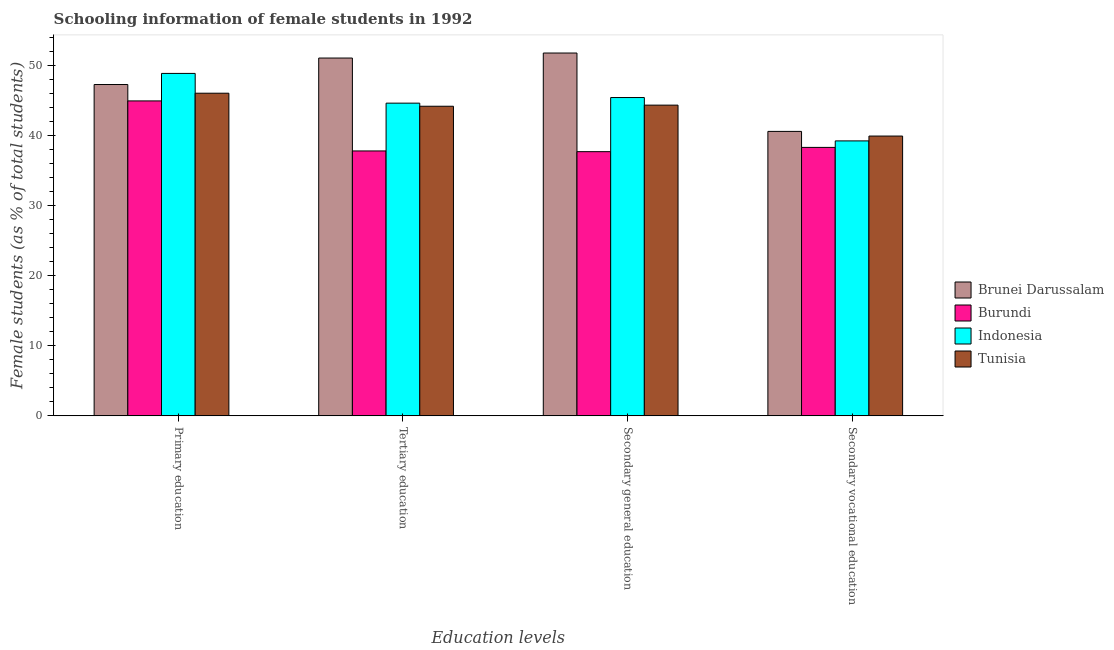How many groups of bars are there?
Provide a short and direct response. 4. Are the number of bars per tick equal to the number of legend labels?
Ensure brevity in your answer.  Yes. Are the number of bars on each tick of the X-axis equal?
Ensure brevity in your answer.  Yes. What is the label of the 2nd group of bars from the left?
Offer a terse response. Tertiary education. What is the percentage of female students in secondary education in Indonesia?
Your answer should be compact. 45.45. Across all countries, what is the maximum percentage of female students in tertiary education?
Provide a succinct answer. 51.09. Across all countries, what is the minimum percentage of female students in secondary education?
Your response must be concise. 37.72. In which country was the percentage of female students in secondary education maximum?
Provide a short and direct response. Brunei Darussalam. In which country was the percentage of female students in tertiary education minimum?
Give a very brief answer. Burundi. What is the total percentage of female students in tertiary education in the graph?
Keep it short and to the point. 177.77. What is the difference between the percentage of female students in secondary education in Tunisia and that in Indonesia?
Your answer should be very brief. -1.08. What is the difference between the percentage of female students in secondary vocational education in Burundi and the percentage of female students in secondary education in Brunei Darussalam?
Make the answer very short. -13.47. What is the average percentage of female students in primary education per country?
Ensure brevity in your answer.  46.81. What is the difference between the percentage of female students in secondary vocational education and percentage of female students in primary education in Brunei Darussalam?
Provide a short and direct response. -6.69. In how many countries, is the percentage of female students in primary education greater than 52 %?
Your answer should be very brief. 0. What is the ratio of the percentage of female students in secondary education in Indonesia to that in Tunisia?
Offer a terse response. 1.02. What is the difference between the highest and the second highest percentage of female students in tertiary education?
Your response must be concise. 6.44. What is the difference between the highest and the lowest percentage of female students in tertiary education?
Give a very brief answer. 13.26. In how many countries, is the percentage of female students in secondary vocational education greater than the average percentage of female students in secondary vocational education taken over all countries?
Keep it short and to the point. 2. What does the 1st bar from the left in Secondary general education represents?
Your answer should be compact. Brunei Darussalam. What does the 2nd bar from the right in Tertiary education represents?
Your answer should be compact. Indonesia. How many bars are there?
Keep it short and to the point. 16. What is the difference between two consecutive major ticks on the Y-axis?
Provide a short and direct response. 10. Where does the legend appear in the graph?
Your answer should be very brief. Center right. How many legend labels are there?
Your answer should be very brief. 4. What is the title of the graph?
Ensure brevity in your answer.  Schooling information of female students in 1992. What is the label or title of the X-axis?
Ensure brevity in your answer.  Education levels. What is the label or title of the Y-axis?
Offer a terse response. Female students (as % of total students). What is the Female students (as % of total students) of Brunei Darussalam in Primary education?
Offer a very short reply. 47.31. What is the Female students (as % of total students) in Burundi in Primary education?
Provide a short and direct response. 44.97. What is the Female students (as % of total students) in Indonesia in Primary education?
Make the answer very short. 48.89. What is the Female students (as % of total students) in Tunisia in Primary education?
Offer a terse response. 46.07. What is the Female students (as % of total students) in Brunei Darussalam in Tertiary education?
Your answer should be compact. 51.09. What is the Female students (as % of total students) of Burundi in Tertiary education?
Make the answer very short. 37.82. What is the Female students (as % of total students) of Indonesia in Tertiary education?
Ensure brevity in your answer.  44.65. What is the Female students (as % of total students) of Tunisia in Tertiary education?
Your response must be concise. 44.21. What is the Female students (as % of total students) in Brunei Darussalam in Secondary general education?
Keep it short and to the point. 51.81. What is the Female students (as % of total students) of Burundi in Secondary general education?
Your answer should be compact. 37.72. What is the Female students (as % of total students) of Indonesia in Secondary general education?
Give a very brief answer. 45.45. What is the Female students (as % of total students) of Tunisia in Secondary general education?
Ensure brevity in your answer.  44.37. What is the Female students (as % of total students) of Brunei Darussalam in Secondary vocational education?
Offer a terse response. 40.62. What is the Female students (as % of total students) of Burundi in Secondary vocational education?
Give a very brief answer. 38.33. What is the Female students (as % of total students) in Indonesia in Secondary vocational education?
Your answer should be compact. 39.26. What is the Female students (as % of total students) in Tunisia in Secondary vocational education?
Offer a very short reply. 39.95. Across all Education levels, what is the maximum Female students (as % of total students) in Brunei Darussalam?
Your answer should be compact. 51.81. Across all Education levels, what is the maximum Female students (as % of total students) of Burundi?
Offer a very short reply. 44.97. Across all Education levels, what is the maximum Female students (as % of total students) in Indonesia?
Give a very brief answer. 48.89. Across all Education levels, what is the maximum Female students (as % of total students) in Tunisia?
Offer a very short reply. 46.07. Across all Education levels, what is the minimum Female students (as % of total students) in Brunei Darussalam?
Provide a short and direct response. 40.62. Across all Education levels, what is the minimum Female students (as % of total students) of Burundi?
Your answer should be compact. 37.72. Across all Education levels, what is the minimum Female students (as % of total students) of Indonesia?
Provide a short and direct response. 39.26. Across all Education levels, what is the minimum Female students (as % of total students) of Tunisia?
Your answer should be very brief. 39.95. What is the total Female students (as % of total students) of Brunei Darussalam in the graph?
Keep it short and to the point. 190.82. What is the total Female students (as % of total students) of Burundi in the graph?
Your answer should be very brief. 158.85. What is the total Female students (as % of total students) in Indonesia in the graph?
Ensure brevity in your answer.  178.25. What is the total Female students (as % of total students) in Tunisia in the graph?
Provide a succinct answer. 174.59. What is the difference between the Female students (as % of total students) of Brunei Darussalam in Primary education and that in Tertiary education?
Your answer should be compact. -3.78. What is the difference between the Female students (as % of total students) of Burundi in Primary education and that in Tertiary education?
Offer a terse response. 7.14. What is the difference between the Female students (as % of total students) in Indonesia in Primary education and that in Tertiary education?
Make the answer very short. 4.25. What is the difference between the Female students (as % of total students) in Tunisia in Primary education and that in Tertiary education?
Ensure brevity in your answer.  1.86. What is the difference between the Female students (as % of total students) of Brunei Darussalam in Primary education and that in Secondary general education?
Ensure brevity in your answer.  -4.5. What is the difference between the Female students (as % of total students) in Burundi in Primary education and that in Secondary general education?
Give a very brief answer. 7.25. What is the difference between the Female students (as % of total students) of Indonesia in Primary education and that in Secondary general education?
Your answer should be compact. 3.44. What is the difference between the Female students (as % of total students) in Tunisia in Primary education and that in Secondary general education?
Give a very brief answer. 1.7. What is the difference between the Female students (as % of total students) in Brunei Darussalam in Primary education and that in Secondary vocational education?
Offer a terse response. 6.69. What is the difference between the Female students (as % of total students) of Burundi in Primary education and that in Secondary vocational education?
Provide a succinct answer. 6.64. What is the difference between the Female students (as % of total students) in Indonesia in Primary education and that in Secondary vocational education?
Your response must be concise. 9.64. What is the difference between the Female students (as % of total students) in Tunisia in Primary education and that in Secondary vocational education?
Offer a terse response. 6.12. What is the difference between the Female students (as % of total students) of Brunei Darussalam in Tertiary education and that in Secondary general education?
Provide a short and direct response. -0.72. What is the difference between the Female students (as % of total students) in Burundi in Tertiary education and that in Secondary general education?
Provide a short and direct response. 0.1. What is the difference between the Female students (as % of total students) in Indonesia in Tertiary education and that in Secondary general education?
Give a very brief answer. -0.8. What is the difference between the Female students (as % of total students) of Tunisia in Tertiary education and that in Secondary general education?
Provide a succinct answer. -0.16. What is the difference between the Female students (as % of total students) of Brunei Darussalam in Tertiary education and that in Secondary vocational education?
Provide a succinct answer. 10.47. What is the difference between the Female students (as % of total students) of Burundi in Tertiary education and that in Secondary vocational education?
Offer a very short reply. -0.51. What is the difference between the Female students (as % of total students) of Indonesia in Tertiary education and that in Secondary vocational education?
Offer a terse response. 5.39. What is the difference between the Female students (as % of total students) of Tunisia in Tertiary education and that in Secondary vocational education?
Offer a very short reply. 4.26. What is the difference between the Female students (as % of total students) of Brunei Darussalam in Secondary general education and that in Secondary vocational education?
Make the answer very short. 11.19. What is the difference between the Female students (as % of total students) in Burundi in Secondary general education and that in Secondary vocational education?
Your answer should be very brief. -0.61. What is the difference between the Female students (as % of total students) in Indonesia in Secondary general education and that in Secondary vocational education?
Provide a short and direct response. 6.19. What is the difference between the Female students (as % of total students) in Tunisia in Secondary general education and that in Secondary vocational education?
Your answer should be compact. 4.42. What is the difference between the Female students (as % of total students) in Brunei Darussalam in Primary education and the Female students (as % of total students) in Burundi in Tertiary education?
Ensure brevity in your answer.  9.48. What is the difference between the Female students (as % of total students) of Brunei Darussalam in Primary education and the Female students (as % of total students) of Indonesia in Tertiary education?
Provide a short and direct response. 2.66. What is the difference between the Female students (as % of total students) of Brunei Darussalam in Primary education and the Female students (as % of total students) of Tunisia in Tertiary education?
Provide a succinct answer. 3.1. What is the difference between the Female students (as % of total students) of Burundi in Primary education and the Female students (as % of total students) of Indonesia in Tertiary education?
Ensure brevity in your answer.  0.32. What is the difference between the Female students (as % of total students) in Burundi in Primary education and the Female students (as % of total students) in Tunisia in Tertiary education?
Your response must be concise. 0.76. What is the difference between the Female students (as % of total students) in Indonesia in Primary education and the Female students (as % of total students) in Tunisia in Tertiary education?
Make the answer very short. 4.69. What is the difference between the Female students (as % of total students) of Brunei Darussalam in Primary education and the Female students (as % of total students) of Burundi in Secondary general education?
Provide a succinct answer. 9.59. What is the difference between the Female students (as % of total students) of Brunei Darussalam in Primary education and the Female students (as % of total students) of Indonesia in Secondary general education?
Give a very brief answer. 1.86. What is the difference between the Female students (as % of total students) in Brunei Darussalam in Primary education and the Female students (as % of total students) in Tunisia in Secondary general education?
Make the answer very short. 2.94. What is the difference between the Female students (as % of total students) of Burundi in Primary education and the Female students (as % of total students) of Indonesia in Secondary general education?
Your response must be concise. -0.48. What is the difference between the Female students (as % of total students) in Burundi in Primary education and the Female students (as % of total students) in Tunisia in Secondary general education?
Provide a succinct answer. 0.6. What is the difference between the Female students (as % of total students) of Indonesia in Primary education and the Female students (as % of total students) of Tunisia in Secondary general education?
Make the answer very short. 4.53. What is the difference between the Female students (as % of total students) in Brunei Darussalam in Primary education and the Female students (as % of total students) in Burundi in Secondary vocational education?
Offer a terse response. 8.98. What is the difference between the Female students (as % of total students) in Brunei Darussalam in Primary education and the Female students (as % of total students) in Indonesia in Secondary vocational education?
Your response must be concise. 8.05. What is the difference between the Female students (as % of total students) in Brunei Darussalam in Primary education and the Female students (as % of total students) in Tunisia in Secondary vocational education?
Offer a very short reply. 7.36. What is the difference between the Female students (as % of total students) of Burundi in Primary education and the Female students (as % of total students) of Indonesia in Secondary vocational education?
Keep it short and to the point. 5.71. What is the difference between the Female students (as % of total students) in Burundi in Primary education and the Female students (as % of total students) in Tunisia in Secondary vocational education?
Provide a succinct answer. 5.02. What is the difference between the Female students (as % of total students) in Indonesia in Primary education and the Female students (as % of total students) in Tunisia in Secondary vocational education?
Make the answer very short. 8.94. What is the difference between the Female students (as % of total students) in Brunei Darussalam in Tertiary education and the Female students (as % of total students) in Burundi in Secondary general education?
Make the answer very short. 13.37. What is the difference between the Female students (as % of total students) in Brunei Darussalam in Tertiary education and the Female students (as % of total students) in Indonesia in Secondary general education?
Your answer should be compact. 5.64. What is the difference between the Female students (as % of total students) of Brunei Darussalam in Tertiary education and the Female students (as % of total students) of Tunisia in Secondary general education?
Keep it short and to the point. 6.72. What is the difference between the Female students (as % of total students) of Burundi in Tertiary education and the Female students (as % of total students) of Indonesia in Secondary general education?
Offer a very short reply. -7.63. What is the difference between the Female students (as % of total students) in Burundi in Tertiary education and the Female students (as % of total students) in Tunisia in Secondary general education?
Give a very brief answer. -6.54. What is the difference between the Female students (as % of total students) in Indonesia in Tertiary education and the Female students (as % of total students) in Tunisia in Secondary general education?
Keep it short and to the point. 0.28. What is the difference between the Female students (as % of total students) of Brunei Darussalam in Tertiary education and the Female students (as % of total students) of Burundi in Secondary vocational education?
Provide a short and direct response. 12.76. What is the difference between the Female students (as % of total students) in Brunei Darussalam in Tertiary education and the Female students (as % of total students) in Indonesia in Secondary vocational education?
Keep it short and to the point. 11.83. What is the difference between the Female students (as % of total students) of Brunei Darussalam in Tertiary education and the Female students (as % of total students) of Tunisia in Secondary vocational education?
Offer a very short reply. 11.14. What is the difference between the Female students (as % of total students) in Burundi in Tertiary education and the Female students (as % of total students) in Indonesia in Secondary vocational education?
Your answer should be compact. -1.43. What is the difference between the Female students (as % of total students) of Burundi in Tertiary education and the Female students (as % of total students) of Tunisia in Secondary vocational education?
Ensure brevity in your answer.  -2.13. What is the difference between the Female students (as % of total students) of Indonesia in Tertiary education and the Female students (as % of total students) of Tunisia in Secondary vocational education?
Provide a short and direct response. 4.7. What is the difference between the Female students (as % of total students) in Brunei Darussalam in Secondary general education and the Female students (as % of total students) in Burundi in Secondary vocational education?
Keep it short and to the point. 13.47. What is the difference between the Female students (as % of total students) of Brunei Darussalam in Secondary general education and the Female students (as % of total students) of Indonesia in Secondary vocational education?
Offer a very short reply. 12.55. What is the difference between the Female students (as % of total students) of Brunei Darussalam in Secondary general education and the Female students (as % of total students) of Tunisia in Secondary vocational education?
Offer a very short reply. 11.86. What is the difference between the Female students (as % of total students) in Burundi in Secondary general education and the Female students (as % of total students) in Indonesia in Secondary vocational education?
Your answer should be very brief. -1.54. What is the difference between the Female students (as % of total students) of Burundi in Secondary general education and the Female students (as % of total students) of Tunisia in Secondary vocational education?
Your answer should be compact. -2.23. What is the difference between the Female students (as % of total students) in Indonesia in Secondary general education and the Female students (as % of total students) in Tunisia in Secondary vocational education?
Your answer should be compact. 5.5. What is the average Female students (as % of total students) of Brunei Darussalam per Education levels?
Provide a succinct answer. 47.7. What is the average Female students (as % of total students) in Burundi per Education levels?
Provide a short and direct response. 39.71. What is the average Female students (as % of total students) in Indonesia per Education levels?
Give a very brief answer. 44.56. What is the average Female students (as % of total students) of Tunisia per Education levels?
Offer a terse response. 43.65. What is the difference between the Female students (as % of total students) in Brunei Darussalam and Female students (as % of total students) in Burundi in Primary education?
Offer a terse response. 2.34. What is the difference between the Female students (as % of total students) of Brunei Darussalam and Female students (as % of total students) of Indonesia in Primary education?
Your answer should be very brief. -1.59. What is the difference between the Female students (as % of total students) in Brunei Darussalam and Female students (as % of total students) in Tunisia in Primary education?
Ensure brevity in your answer.  1.24. What is the difference between the Female students (as % of total students) of Burundi and Female students (as % of total students) of Indonesia in Primary education?
Your answer should be compact. -3.93. What is the difference between the Female students (as % of total students) in Burundi and Female students (as % of total students) in Tunisia in Primary education?
Offer a very short reply. -1.1. What is the difference between the Female students (as % of total students) of Indonesia and Female students (as % of total students) of Tunisia in Primary education?
Your answer should be very brief. 2.83. What is the difference between the Female students (as % of total students) in Brunei Darussalam and Female students (as % of total students) in Burundi in Tertiary education?
Keep it short and to the point. 13.26. What is the difference between the Female students (as % of total students) of Brunei Darussalam and Female students (as % of total students) of Indonesia in Tertiary education?
Offer a very short reply. 6.44. What is the difference between the Female students (as % of total students) in Brunei Darussalam and Female students (as % of total students) in Tunisia in Tertiary education?
Provide a succinct answer. 6.88. What is the difference between the Female students (as % of total students) of Burundi and Female students (as % of total students) of Indonesia in Tertiary education?
Provide a succinct answer. -6.82. What is the difference between the Female students (as % of total students) of Burundi and Female students (as % of total students) of Tunisia in Tertiary education?
Make the answer very short. -6.38. What is the difference between the Female students (as % of total students) in Indonesia and Female students (as % of total students) in Tunisia in Tertiary education?
Your response must be concise. 0.44. What is the difference between the Female students (as % of total students) of Brunei Darussalam and Female students (as % of total students) of Burundi in Secondary general education?
Offer a very short reply. 14.08. What is the difference between the Female students (as % of total students) of Brunei Darussalam and Female students (as % of total students) of Indonesia in Secondary general education?
Your response must be concise. 6.36. What is the difference between the Female students (as % of total students) of Brunei Darussalam and Female students (as % of total students) of Tunisia in Secondary general education?
Keep it short and to the point. 7.44. What is the difference between the Female students (as % of total students) of Burundi and Female students (as % of total students) of Indonesia in Secondary general education?
Your answer should be compact. -7.73. What is the difference between the Female students (as % of total students) in Burundi and Female students (as % of total students) in Tunisia in Secondary general education?
Your response must be concise. -6.64. What is the difference between the Female students (as % of total students) in Indonesia and Female students (as % of total students) in Tunisia in Secondary general education?
Give a very brief answer. 1.08. What is the difference between the Female students (as % of total students) in Brunei Darussalam and Female students (as % of total students) in Burundi in Secondary vocational education?
Offer a very short reply. 2.29. What is the difference between the Female students (as % of total students) in Brunei Darussalam and Female students (as % of total students) in Indonesia in Secondary vocational education?
Give a very brief answer. 1.36. What is the difference between the Female students (as % of total students) of Brunei Darussalam and Female students (as % of total students) of Tunisia in Secondary vocational education?
Provide a succinct answer. 0.67. What is the difference between the Female students (as % of total students) of Burundi and Female students (as % of total students) of Indonesia in Secondary vocational education?
Give a very brief answer. -0.93. What is the difference between the Female students (as % of total students) of Burundi and Female students (as % of total students) of Tunisia in Secondary vocational education?
Give a very brief answer. -1.62. What is the difference between the Female students (as % of total students) of Indonesia and Female students (as % of total students) of Tunisia in Secondary vocational education?
Your answer should be compact. -0.69. What is the ratio of the Female students (as % of total students) in Brunei Darussalam in Primary education to that in Tertiary education?
Give a very brief answer. 0.93. What is the ratio of the Female students (as % of total students) of Burundi in Primary education to that in Tertiary education?
Offer a very short reply. 1.19. What is the ratio of the Female students (as % of total students) in Indonesia in Primary education to that in Tertiary education?
Make the answer very short. 1.1. What is the ratio of the Female students (as % of total students) of Tunisia in Primary education to that in Tertiary education?
Your answer should be very brief. 1.04. What is the ratio of the Female students (as % of total students) of Brunei Darussalam in Primary education to that in Secondary general education?
Keep it short and to the point. 0.91. What is the ratio of the Female students (as % of total students) in Burundi in Primary education to that in Secondary general education?
Keep it short and to the point. 1.19. What is the ratio of the Female students (as % of total students) in Indonesia in Primary education to that in Secondary general education?
Provide a short and direct response. 1.08. What is the ratio of the Female students (as % of total students) in Tunisia in Primary education to that in Secondary general education?
Your answer should be very brief. 1.04. What is the ratio of the Female students (as % of total students) of Brunei Darussalam in Primary education to that in Secondary vocational education?
Your answer should be very brief. 1.16. What is the ratio of the Female students (as % of total students) in Burundi in Primary education to that in Secondary vocational education?
Give a very brief answer. 1.17. What is the ratio of the Female students (as % of total students) of Indonesia in Primary education to that in Secondary vocational education?
Ensure brevity in your answer.  1.25. What is the ratio of the Female students (as % of total students) in Tunisia in Primary education to that in Secondary vocational education?
Keep it short and to the point. 1.15. What is the ratio of the Female students (as % of total students) of Brunei Darussalam in Tertiary education to that in Secondary general education?
Your answer should be compact. 0.99. What is the ratio of the Female students (as % of total students) of Indonesia in Tertiary education to that in Secondary general education?
Your answer should be compact. 0.98. What is the ratio of the Female students (as % of total students) of Brunei Darussalam in Tertiary education to that in Secondary vocational education?
Provide a short and direct response. 1.26. What is the ratio of the Female students (as % of total students) of Burundi in Tertiary education to that in Secondary vocational education?
Your answer should be very brief. 0.99. What is the ratio of the Female students (as % of total students) in Indonesia in Tertiary education to that in Secondary vocational education?
Offer a terse response. 1.14. What is the ratio of the Female students (as % of total students) of Tunisia in Tertiary education to that in Secondary vocational education?
Give a very brief answer. 1.11. What is the ratio of the Female students (as % of total students) of Brunei Darussalam in Secondary general education to that in Secondary vocational education?
Give a very brief answer. 1.28. What is the ratio of the Female students (as % of total students) of Burundi in Secondary general education to that in Secondary vocational education?
Offer a terse response. 0.98. What is the ratio of the Female students (as % of total students) of Indonesia in Secondary general education to that in Secondary vocational education?
Provide a succinct answer. 1.16. What is the ratio of the Female students (as % of total students) in Tunisia in Secondary general education to that in Secondary vocational education?
Keep it short and to the point. 1.11. What is the difference between the highest and the second highest Female students (as % of total students) in Brunei Darussalam?
Provide a short and direct response. 0.72. What is the difference between the highest and the second highest Female students (as % of total students) in Burundi?
Provide a short and direct response. 6.64. What is the difference between the highest and the second highest Female students (as % of total students) in Indonesia?
Your response must be concise. 3.44. What is the difference between the highest and the second highest Female students (as % of total students) of Tunisia?
Your response must be concise. 1.7. What is the difference between the highest and the lowest Female students (as % of total students) in Brunei Darussalam?
Offer a terse response. 11.19. What is the difference between the highest and the lowest Female students (as % of total students) in Burundi?
Provide a succinct answer. 7.25. What is the difference between the highest and the lowest Female students (as % of total students) in Indonesia?
Your answer should be compact. 9.64. What is the difference between the highest and the lowest Female students (as % of total students) of Tunisia?
Provide a succinct answer. 6.12. 